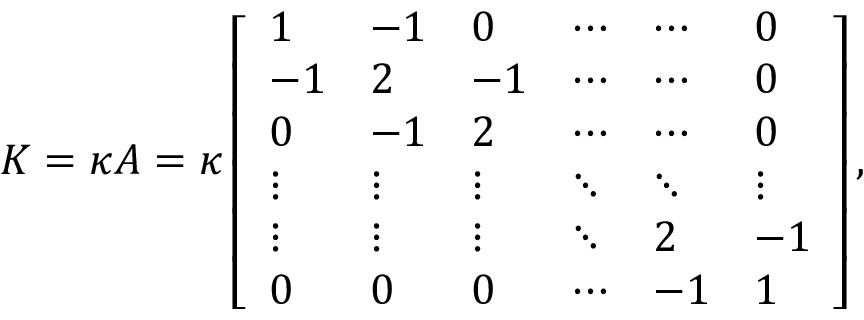Convert formula to latex. <formula><loc_0><loc_0><loc_500><loc_500>K = \kappa A = \kappa \left [ \begin{array} { l l l l l l } { 1 } & { - 1 } & { 0 } & { \cdots } & { \cdots } & { 0 } \\ { - 1 } & { 2 } & { - 1 } & { \cdots } & { \cdots } & { 0 } \\ { 0 } & { - 1 } & { 2 } & { \cdots } & { \cdots } & { 0 } \\ { \vdots } & { \vdots } & { \vdots } & { \ddots } & { \ddots } & { \vdots } \\ { \vdots } & { \vdots } & { \vdots } & { \ddots } & { 2 } & { - 1 } \\ { 0 } & { 0 } & { 0 } & { \cdots } & { - 1 } & { 1 } \end{array} \right ] ,</formula> 